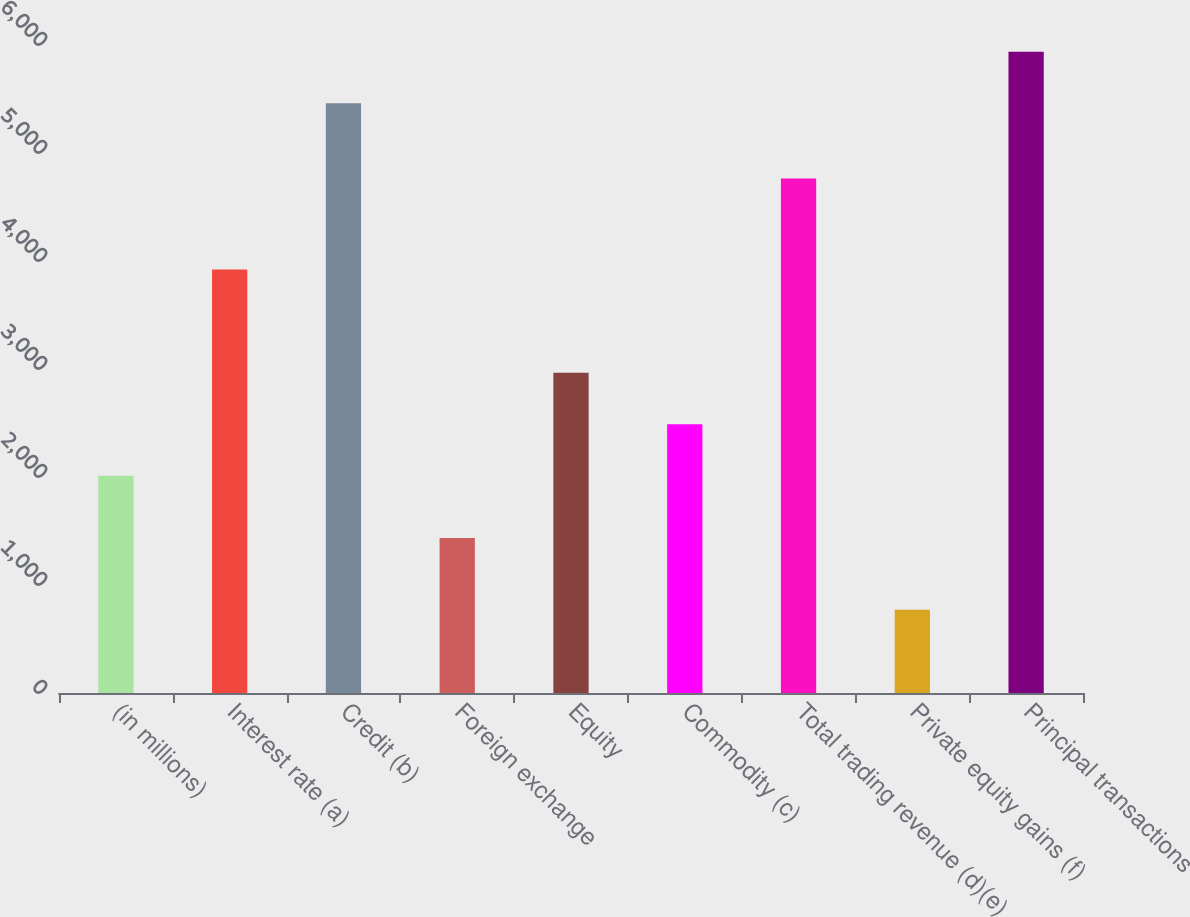Convert chart. <chart><loc_0><loc_0><loc_500><loc_500><bar_chart><fcel>(in millions)<fcel>Interest rate (a)<fcel>Credit (b)<fcel>Foreign exchange<fcel>Equity<fcel>Commodity (c)<fcel>Total trading revenue (d)(e)<fcel>Private equity gains (f)<fcel>Principal transactions<nl><fcel>2012<fcel>3922<fcel>5460<fcel>1436<fcel>2965<fcel>2488.5<fcel>4765<fcel>771<fcel>5936.5<nl></chart> 